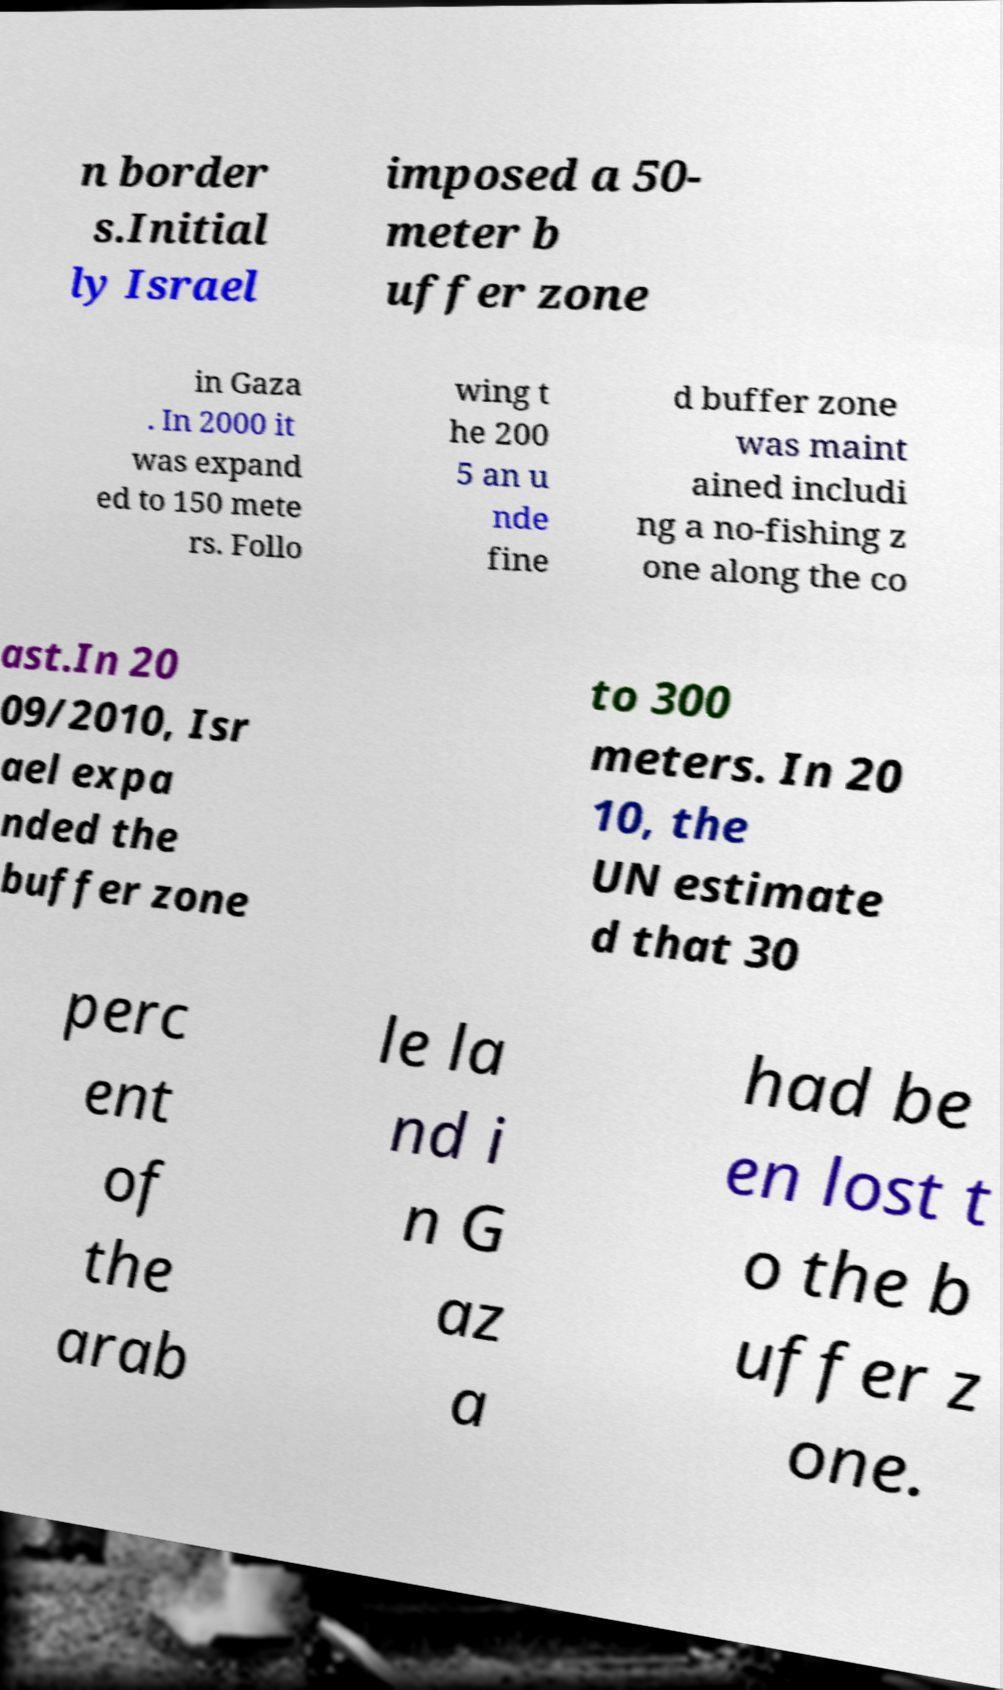Could you assist in decoding the text presented in this image and type it out clearly? n border s.Initial ly Israel imposed a 50- meter b uffer zone in Gaza . In 2000 it was expand ed to 150 mete rs. Follo wing t he 200 5 an u nde fine d buffer zone was maint ained includi ng a no-fishing z one along the co ast.In 20 09/2010, Isr ael expa nded the buffer zone to 300 meters. In 20 10, the UN estimate d that 30 perc ent of the arab le la nd i n G az a had be en lost t o the b uffer z one. 